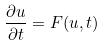Convert formula to latex. <formula><loc_0><loc_0><loc_500><loc_500>\frac { \partial u } { \partial t } = F ( u , t )</formula> 